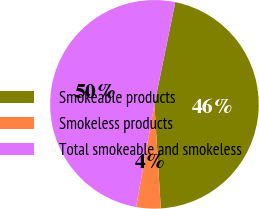<chart> <loc_0><loc_0><loc_500><loc_500><pie_chart><fcel>Smokeable products<fcel>Smokeless products<fcel>Total smokeable and smokeless<nl><fcel>45.82%<fcel>3.78%<fcel>50.4%<nl></chart> 